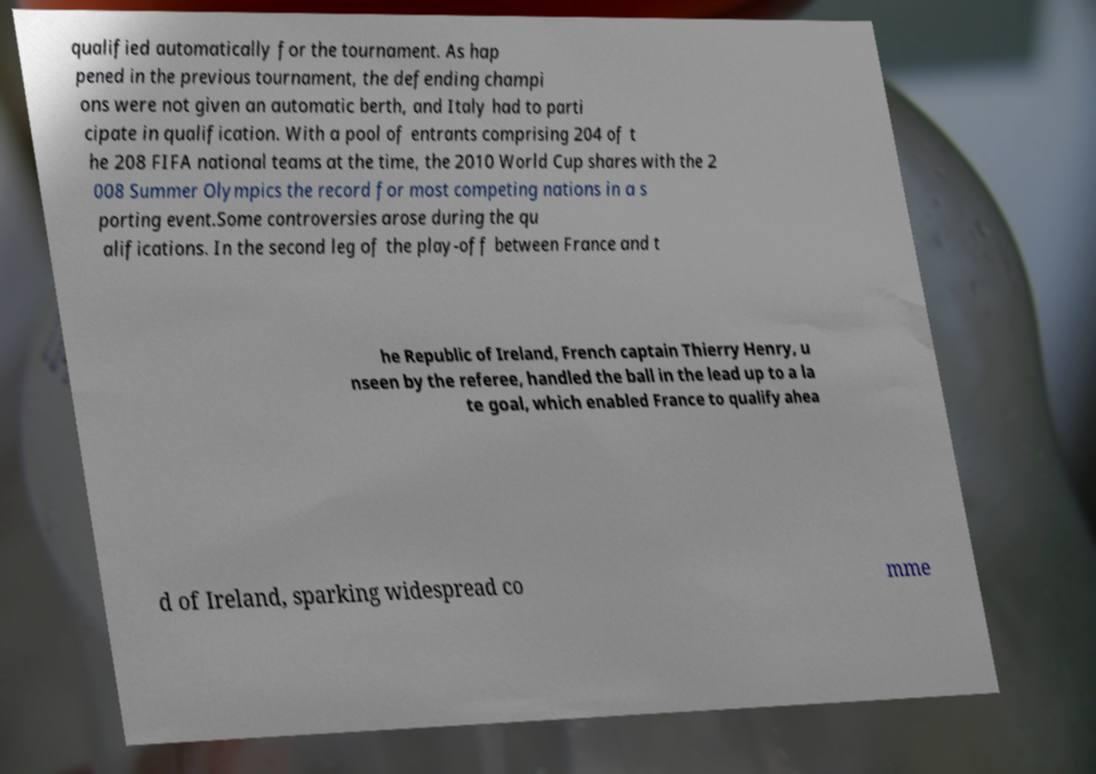I need the written content from this picture converted into text. Can you do that? qualified automatically for the tournament. As hap pened in the previous tournament, the defending champi ons were not given an automatic berth, and Italy had to parti cipate in qualification. With a pool of entrants comprising 204 of t he 208 FIFA national teams at the time, the 2010 World Cup shares with the 2 008 Summer Olympics the record for most competing nations in a s porting event.Some controversies arose during the qu alifications. In the second leg of the play-off between France and t he Republic of Ireland, French captain Thierry Henry, u nseen by the referee, handled the ball in the lead up to a la te goal, which enabled France to qualify ahea d of Ireland, sparking widespread co mme 